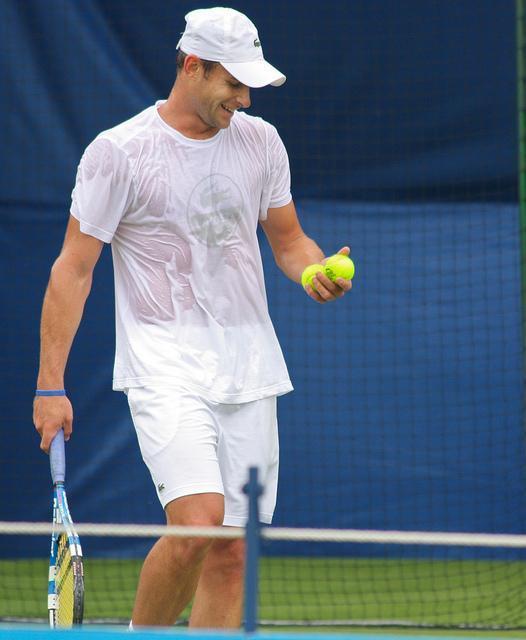How many balls the man holding?
Give a very brief answer. 2. 